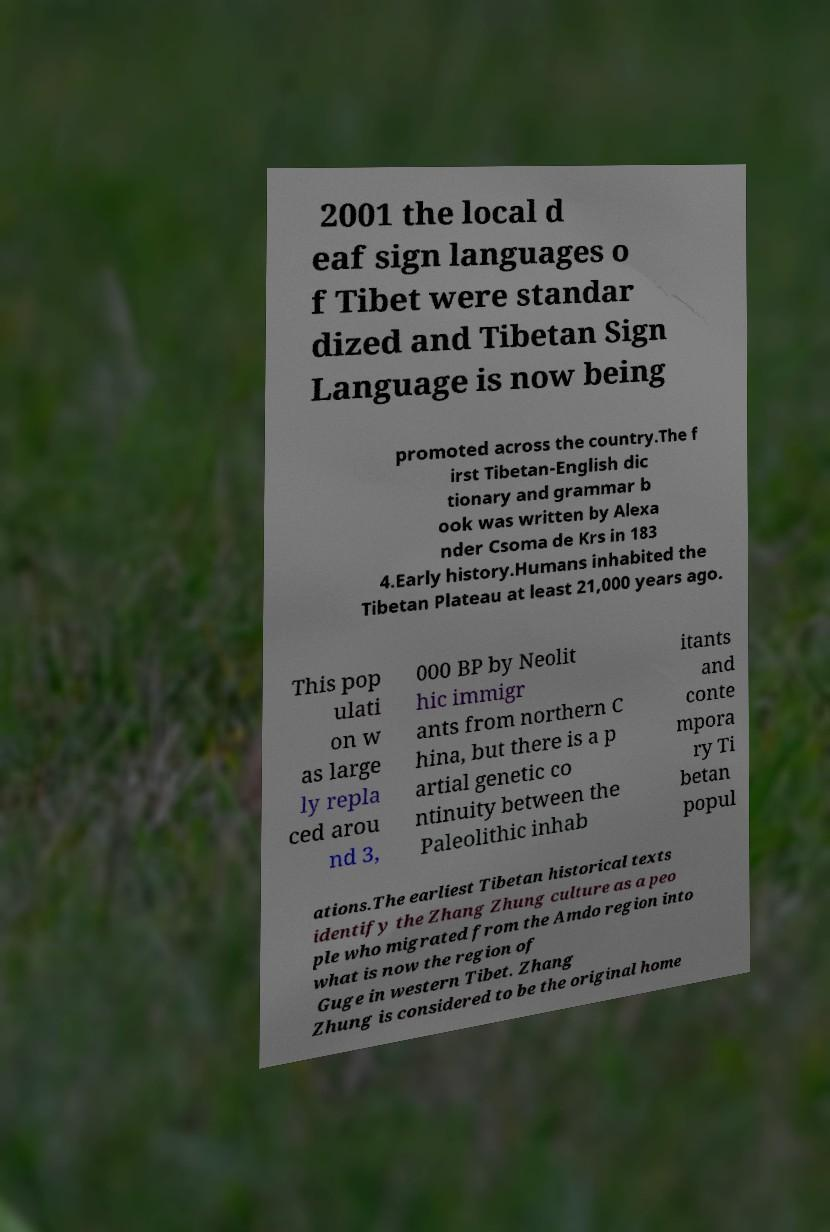There's text embedded in this image that I need extracted. Can you transcribe it verbatim? 2001 the local d eaf sign languages o f Tibet were standar dized and Tibetan Sign Language is now being promoted across the country.The f irst Tibetan-English dic tionary and grammar b ook was written by Alexa nder Csoma de Krs in 183 4.Early history.Humans inhabited the Tibetan Plateau at least 21,000 years ago. This pop ulati on w as large ly repla ced arou nd 3, 000 BP by Neolit hic immigr ants from northern C hina, but there is a p artial genetic co ntinuity between the Paleolithic inhab itants and conte mpora ry Ti betan popul ations.The earliest Tibetan historical texts identify the Zhang Zhung culture as a peo ple who migrated from the Amdo region into what is now the region of Guge in western Tibet. Zhang Zhung is considered to be the original home 